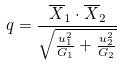Convert formula to latex. <formula><loc_0><loc_0><loc_500><loc_500>q = \frac { \overline { X } _ { 1 } \cdot \overline { X } _ { 2 } } { \sqrt { \frac { u _ { 1 } ^ { 2 } } { G _ { 1 } } + \frac { u _ { 2 } ^ { 2 } } { G _ { 2 } } } }</formula> 